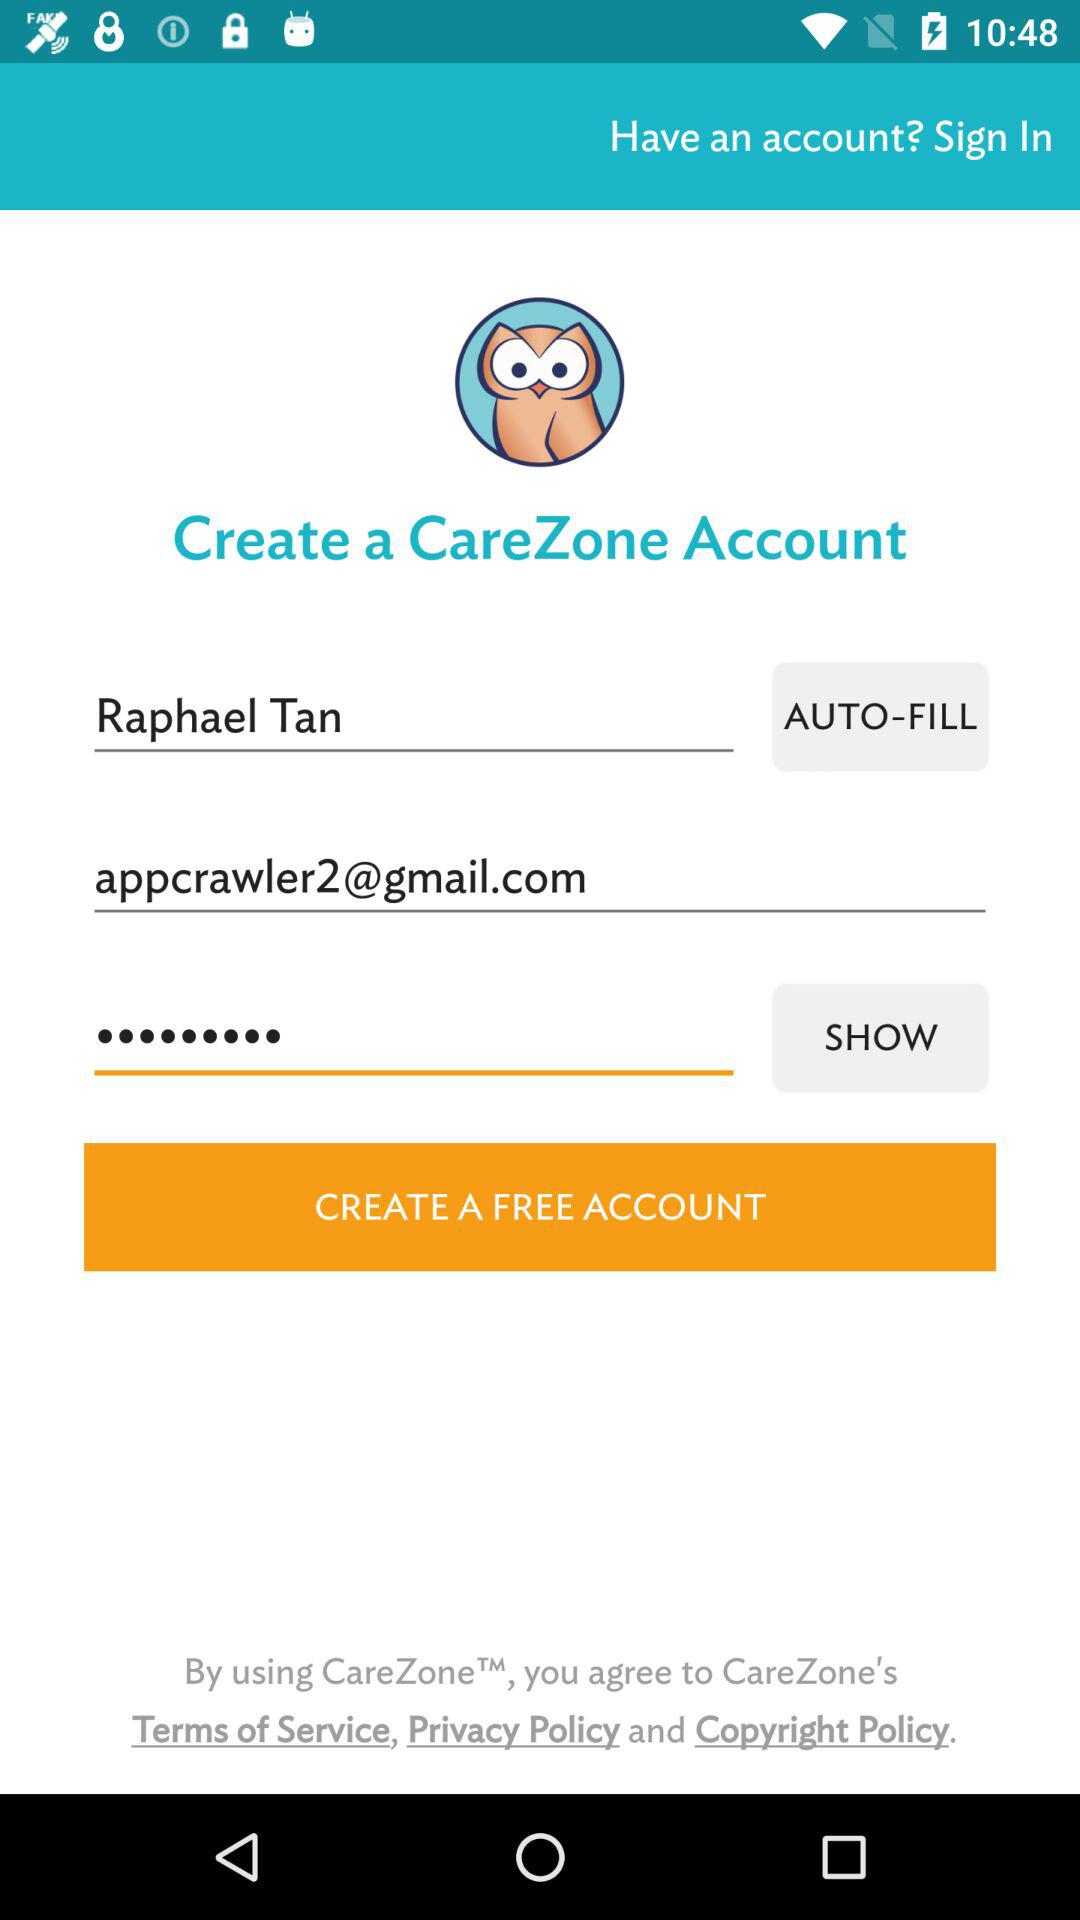What is the profile name? The profile name is Raphael Tan. 